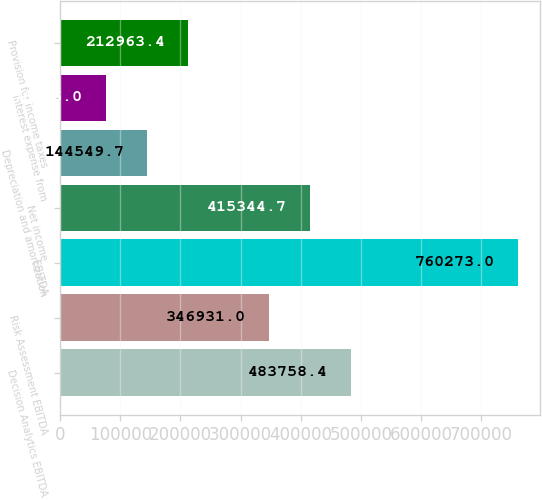Convert chart. <chart><loc_0><loc_0><loc_500><loc_500><bar_chart><fcel>Decision Analytics EBITDA<fcel>Risk Assessment EBITDA<fcel>EBITDA<fcel>Net income<fcel>Depreciation and amortization<fcel>Interest expense from<fcel>Provision for income taxes<nl><fcel>483758<fcel>346931<fcel>760273<fcel>415345<fcel>144550<fcel>76136<fcel>212963<nl></chart> 